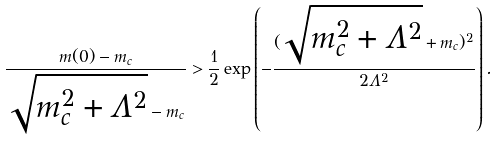Convert formula to latex. <formula><loc_0><loc_0><loc_500><loc_500>\frac { m ( 0 ) - m _ { c } } { \sqrt { m ^ { 2 } _ { c } + \Lambda ^ { 2 } } - m _ { c } } > \frac { 1 } { 2 } \exp \left ( - \frac { ( \sqrt { m ^ { 2 } _ { c } + \Lambda ^ { 2 } } + m _ { c } ) ^ { 2 } } { 2 \Lambda ^ { 2 } } \right ) .</formula> 